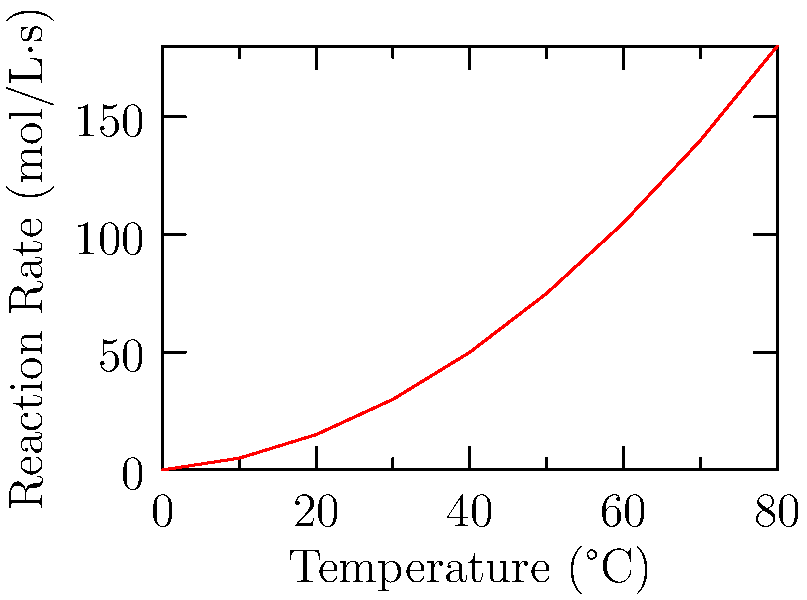Based on the graph showing the relationship between temperature and reaction rate in a chemical experiment, what type of relationship does this data suggest? How does this support the importance of hands-on lab experiments in understanding chemical kinetics? To answer this question, let's analyze the graph step-by-step:

1. Observe the overall trend: As temperature increases, the reaction rate also increases.

2. Note the shape of the curve: It's not a straight line, but rather a curve that becomes steeper as temperature increases.

3. This curved relationship suggests a non-linear relationship between temperature and reaction rate.

4. In chemical kinetics, this type of curve typically represents an exponential relationship, which can be described by the Arrhenius equation:

   $$ k = Ae^{-E_a/RT} $$

   where $k$ is the reaction rate constant, $A$ is the pre-exponential factor, $E_a$ is the activation energy, $R$ is the gas constant, and $T$ is the temperature in Kelvin.

5. The exponential nature of this relationship explains why the reaction rate increases more rapidly at higher temperatures.

This graph supports the importance of hands-on lab experiments in understanding chemical kinetics because:

a) It demonstrates a complex relationship that might be difficult to grasp through theoretical study alone.
b) Students can directly observe how temperature affects reaction rates in real-time.
c) The data collection process reinforces the scientific method and data analysis skills.
d) It provides a tangible example of how mathematical models (like the Arrhenius equation) relate to real-world phenomena.
Answer: Exponential relationship; hands-on experiments visualize complex kinetics concepts. 